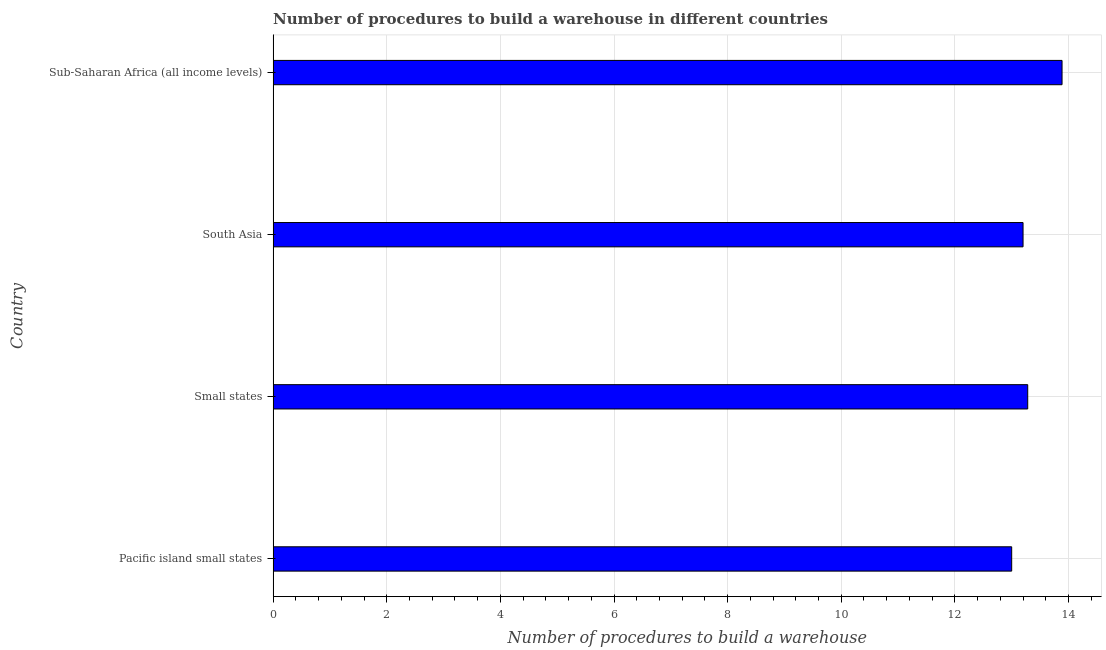Does the graph contain grids?
Your response must be concise. Yes. What is the title of the graph?
Offer a terse response. Number of procedures to build a warehouse in different countries. What is the label or title of the X-axis?
Provide a short and direct response. Number of procedures to build a warehouse. What is the number of procedures to build a warehouse in Small states?
Your response must be concise. 13.28. Across all countries, what is the maximum number of procedures to build a warehouse?
Your answer should be compact. 13.89. Across all countries, what is the minimum number of procedures to build a warehouse?
Provide a short and direct response. 13. In which country was the number of procedures to build a warehouse maximum?
Make the answer very short. Sub-Saharan Africa (all income levels). In which country was the number of procedures to build a warehouse minimum?
Your answer should be very brief. Pacific island small states. What is the sum of the number of procedures to build a warehouse?
Your response must be concise. 53.37. What is the difference between the number of procedures to build a warehouse in Small states and Sub-Saharan Africa (all income levels)?
Your response must be concise. -0.6. What is the average number of procedures to build a warehouse per country?
Make the answer very short. 13.34. What is the median number of procedures to build a warehouse?
Ensure brevity in your answer.  13.24. In how many countries, is the number of procedures to build a warehouse greater than 4.8 ?
Ensure brevity in your answer.  4. What is the ratio of the number of procedures to build a warehouse in Small states to that in South Asia?
Make the answer very short. 1.01. Is the number of procedures to build a warehouse in Pacific island small states less than that in South Asia?
Your response must be concise. Yes. Is the difference between the number of procedures to build a warehouse in Pacific island small states and Small states greater than the difference between any two countries?
Ensure brevity in your answer.  No. What is the difference between the highest and the second highest number of procedures to build a warehouse?
Offer a very short reply. 0.6. Is the sum of the number of procedures to build a warehouse in Pacific island small states and Sub-Saharan Africa (all income levels) greater than the maximum number of procedures to build a warehouse across all countries?
Your answer should be compact. Yes. What is the difference between the highest and the lowest number of procedures to build a warehouse?
Offer a very short reply. 0.89. In how many countries, is the number of procedures to build a warehouse greater than the average number of procedures to build a warehouse taken over all countries?
Make the answer very short. 1. Are the values on the major ticks of X-axis written in scientific E-notation?
Your answer should be compact. No. What is the Number of procedures to build a warehouse in Small states?
Provide a short and direct response. 13.28. What is the Number of procedures to build a warehouse in Sub-Saharan Africa (all income levels)?
Keep it short and to the point. 13.89. What is the difference between the Number of procedures to build a warehouse in Pacific island small states and Small states?
Offer a very short reply. -0.28. What is the difference between the Number of procedures to build a warehouse in Pacific island small states and South Asia?
Keep it short and to the point. -0.2. What is the difference between the Number of procedures to build a warehouse in Pacific island small states and Sub-Saharan Africa (all income levels)?
Your answer should be very brief. -0.89. What is the difference between the Number of procedures to build a warehouse in Small states and South Asia?
Provide a short and direct response. 0.08. What is the difference between the Number of procedures to build a warehouse in Small states and Sub-Saharan Africa (all income levels)?
Offer a very short reply. -0.6. What is the difference between the Number of procedures to build a warehouse in South Asia and Sub-Saharan Africa (all income levels)?
Provide a short and direct response. -0.69. What is the ratio of the Number of procedures to build a warehouse in Pacific island small states to that in Sub-Saharan Africa (all income levels)?
Keep it short and to the point. 0.94. What is the ratio of the Number of procedures to build a warehouse in Small states to that in South Asia?
Your answer should be very brief. 1.01. What is the ratio of the Number of procedures to build a warehouse in Small states to that in Sub-Saharan Africa (all income levels)?
Ensure brevity in your answer.  0.96. What is the ratio of the Number of procedures to build a warehouse in South Asia to that in Sub-Saharan Africa (all income levels)?
Make the answer very short. 0.95. 